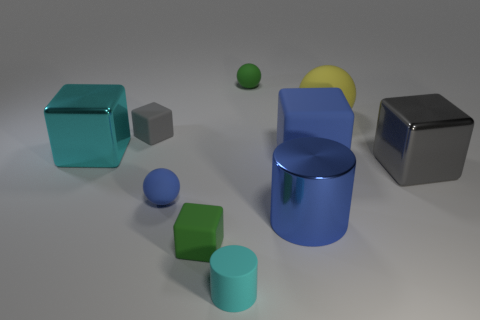What color is the large sphere that is the same material as the tiny green ball?
Give a very brief answer. Yellow. Is the number of yellow spheres less than the number of purple metal cylinders?
Make the answer very short. No. How many brown objects are small matte cubes or big shiny cylinders?
Provide a succinct answer. 0. How many tiny rubber balls are both to the left of the small cyan cylinder and on the right side of the small cyan rubber cylinder?
Provide a succinct answer. 0. Are the blue block and the big cylinder made of the same material?
Your answer should be compact. No. What shape is the blue rubber object that is the same size as the gray matte thing?
Give a very brief answer. Sphere. Is the number of large blue things greater than the number of large yellow blocks?
Ensure brevity in your answer.  Yes. What material is the cube that is in front of the big blue rubber block and behind the small blue thing?
Your answer should be very brief. Metal. How many other objects are the same material as the big cylinder?
Give a very brief answer. 2. What number of large objects are the same color as the tiny matte cylinder?
Provide a succinct answer. 1. 